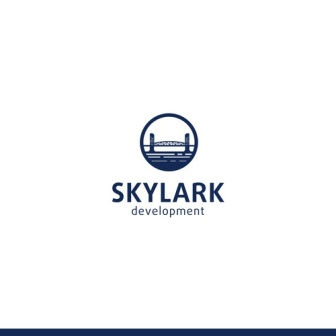Can you describe the visual style and elements of the logo? The logo for 'Skylark Development' adopts a minimalist and modern visual style. Key elements include a blue circle with a white outline at the center, within which a city skyline with various stylized buildings and a bridge is depicted in blue. The use of simple geometric shapes and silhouettes creates a clean and professional look. The text 'SKYLARK' is boldly displayed above the circle in blue capital letters, while 'development' is presented below in a smaller, more subdued font. The color palette is straightforward, using blue to convey trust and reliability, paired with white for clarity and simplicity. 